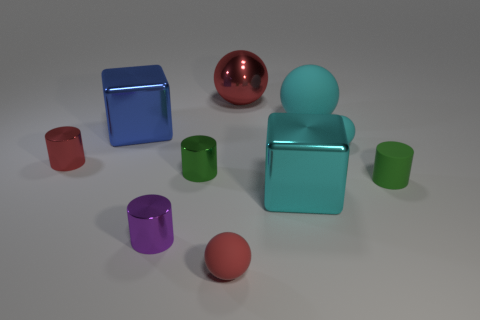Subtract all metal cylinders. How many cylinders are left? 1 Subtract 1 cylinders. How many cylinders are left? 3 Subtract all brown cylinders. Subtract all green balls. How many cylinders are left? 4 Subtract all cylinders. How many objects are left? 6 Subtract 0 brown cylinders. How many objects are left? 10 Subtract all big shiny blocks. Subtract all blue cubes. How many objects are left? 7 Add 2 cyan matte spheres. How many cyan matte spheres are left? 4 Add 4 big cyan metallic things. How many big cyan metallic things exist? 5 